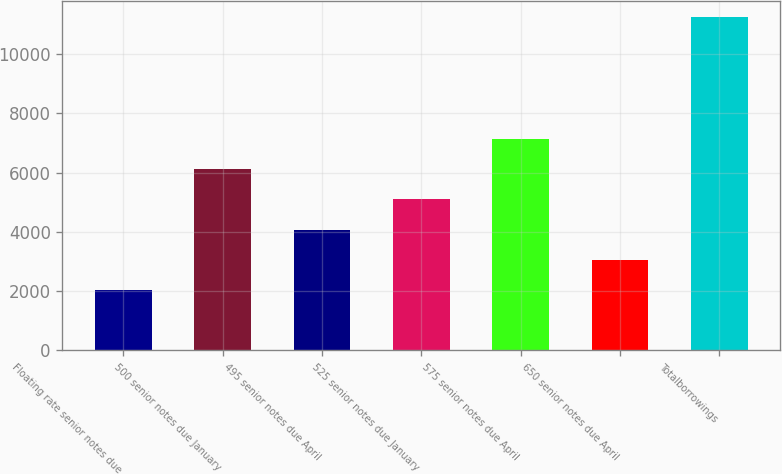Convert chart to OTSL. <chart><loc_0><loc_0><loc_500><loc_500><bar_chart><fcel>Floating rate senior notes due<fcel>500 senior notes due January<fcel>495 senior notes due April<fcel>525 senior notes due January<fcel>575 senior notes due April<fcel>650 senior notes due April<fcel>Totalborrowings<nl><fcel>2023.4<fcel>6117<fcel>4070.2<fcel>5093.6<fcel>7140.4<fcel>3046.8<fcel>11234<nl></chart> 